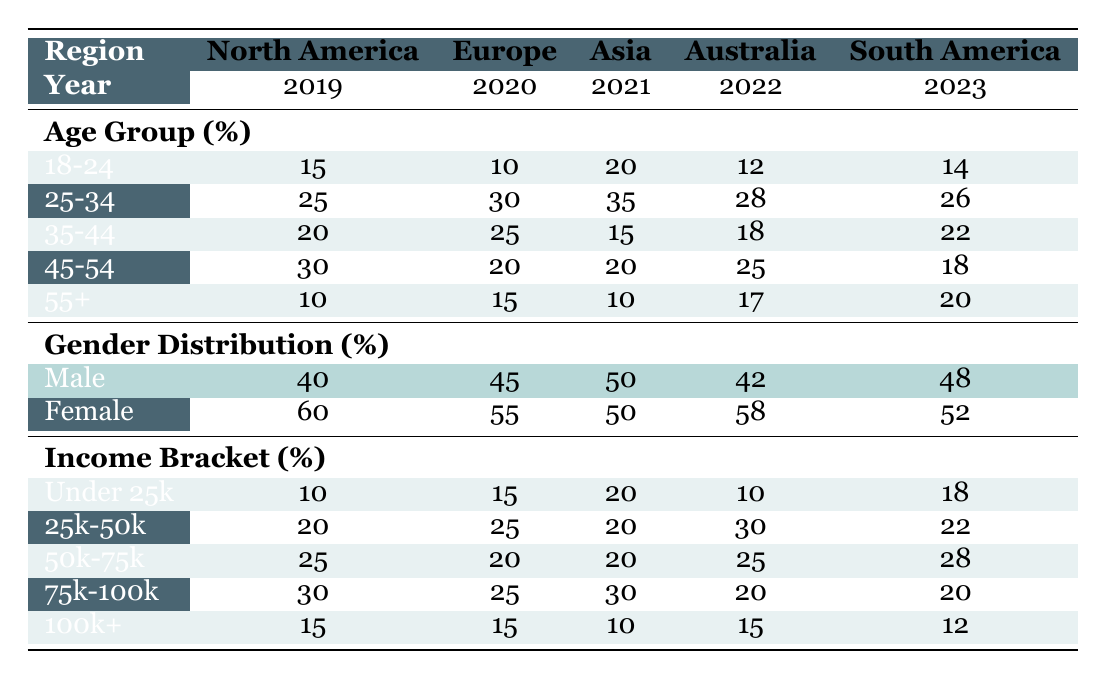What percentage of the audience in Asia in 2021 was aged 35-44? Looking at the table under the Asia column for the year 2021, the age group 35-44 shows a percentage of 15.
Answer: 15 Which region had the highest percentage of male audience members in 2020? In the year 2020, examining the gender distribution row, Europe had the highest percentage of male audience members at 45%.
Answer: Europe What is the combined percentage of audience members aged 25-34 in all regions for 2019 to 2023? Summing the percentages of age group 25-34 across all regions: North America (25) + Europe (30) + Asia (35) + Australia (28) + South America (26) equals 174.
Answer: 174 Did more than 50% of the audience in North America in 2019 earn above 50k? The income bracket percentages for North America in 2019 show that the brackets of 75k-100k (30%) and 100k+ (15%) combined yield 45%, which is less than 50%.
Answer: No What is the average percentage of the audience aged 55+ across all years? To find the average percentage for the age group 55+, we sum the values from each year and region: North America (10) + Europe (15) + Asia (10) + Australia (17) + South America (20) equals 72. Dividing by 5 gives an average of 14.4%.
Answer: 14.4 Which year and region had the highest percentage of the audience earning between 25k-50k? The row for the income bracket 25k-50k shows that Australia in 2022 had the highest percentage at 30%, compared to other regions and years.
Answer: Australia in 2022 What percentage of the audience in Europe in 2020 was female? The gender distribution for Europe in 2020 lists 55% as female.
Answer: 55 Is the 45-54 age group always larger than the 35-44 age group across all years? Inspecting each year, for 2019, 45-54 (30) is greater than 35-44 (20); in 2020, 45-54 (20) is less than 35-44 (25); in 2021, they are equal (20); in 2022, 45-54 (25) is greater than 35-44 (18); in 2023, 45-54 (18) is less than 35-44 (22). Therefore, it is not always larger.
Answer: No 